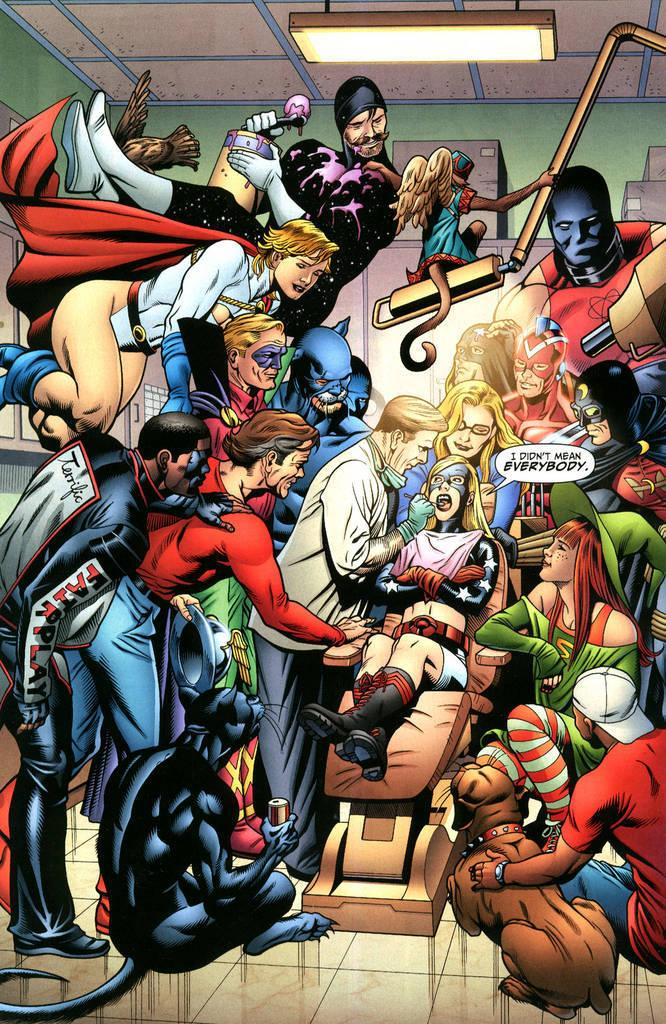What type of image is being described? The image is animated. How many people are present in the image? There are many people in the image. Are there any animals in the image? Yes, there are animals in the image. What can be seen in the background of the image? There is a wall in the background of the image. Where is the light located in the image? There is a light at the top of the image. What time of day is depicted in the image based on the hour shown on the clock? There is no clock present in the image, so it is not possible to determine the time of day based on an hour. 